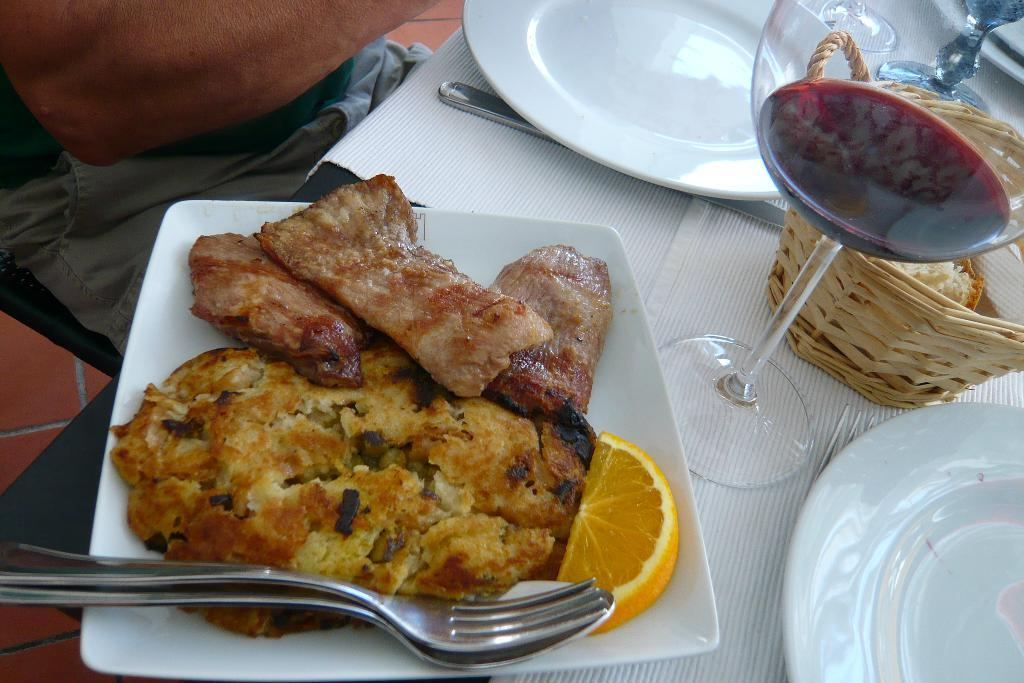What is the primary subject in the image? There is a person sitting in the image. How much of the person is visible? The person is partially visible. What other objects can be seen in the image? There are objects in the image, including a basket, food, plates, a knife, a spoon, a fork, table mats, and a glass with liquid. What type of bell can be heard ringing in the image? There is no bell present in the image, and therefore no sound can be heard. Can you describe the downtown area visible in the image? There is no downtown area visible in the image; it is focused on a person sitting and the objects around them. 